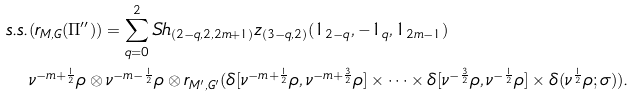<formula> <loc_0><loc_0><loc_500><loc_500>s . s . & ( r _ { M , G } ( \Pi ^ { \prime \prime } ) ) = \sum _ { q = 0 } ^ { 2 } S h _ { ( 2 - q , 2 , 2 m + 1 ) } z _ { ( 3 - q , 2 ) } ( 1 _ { 2 - q } , - 1 _ { q } , 1 _ { 2 m - 1 } ) \, \\ & \nu ^ { - m + \frac { 1 } { 2 } } \rho \otimes \nu ^ { - m - \frac { 1 } { 2 } } \rho \otimes r _ { M ^ { \prime } , G ^ { \prime } } ( \delta [ \nu ^ { - m + \frac { 1 } { 2 } } \rho , \nu ^ { - m + \frac { 3 } { 2 } } \rho ] \times \cdots \times \delta [ \nu ^ { - \frac { 3 } { 2 } } \rho , \nu ^ { - \frac { 1 } { 2 } } \rho ] \times \delta ( \nu ^ { \frac { 1 } { 2 } } \rho ; \sigma ) ) .</formula> 